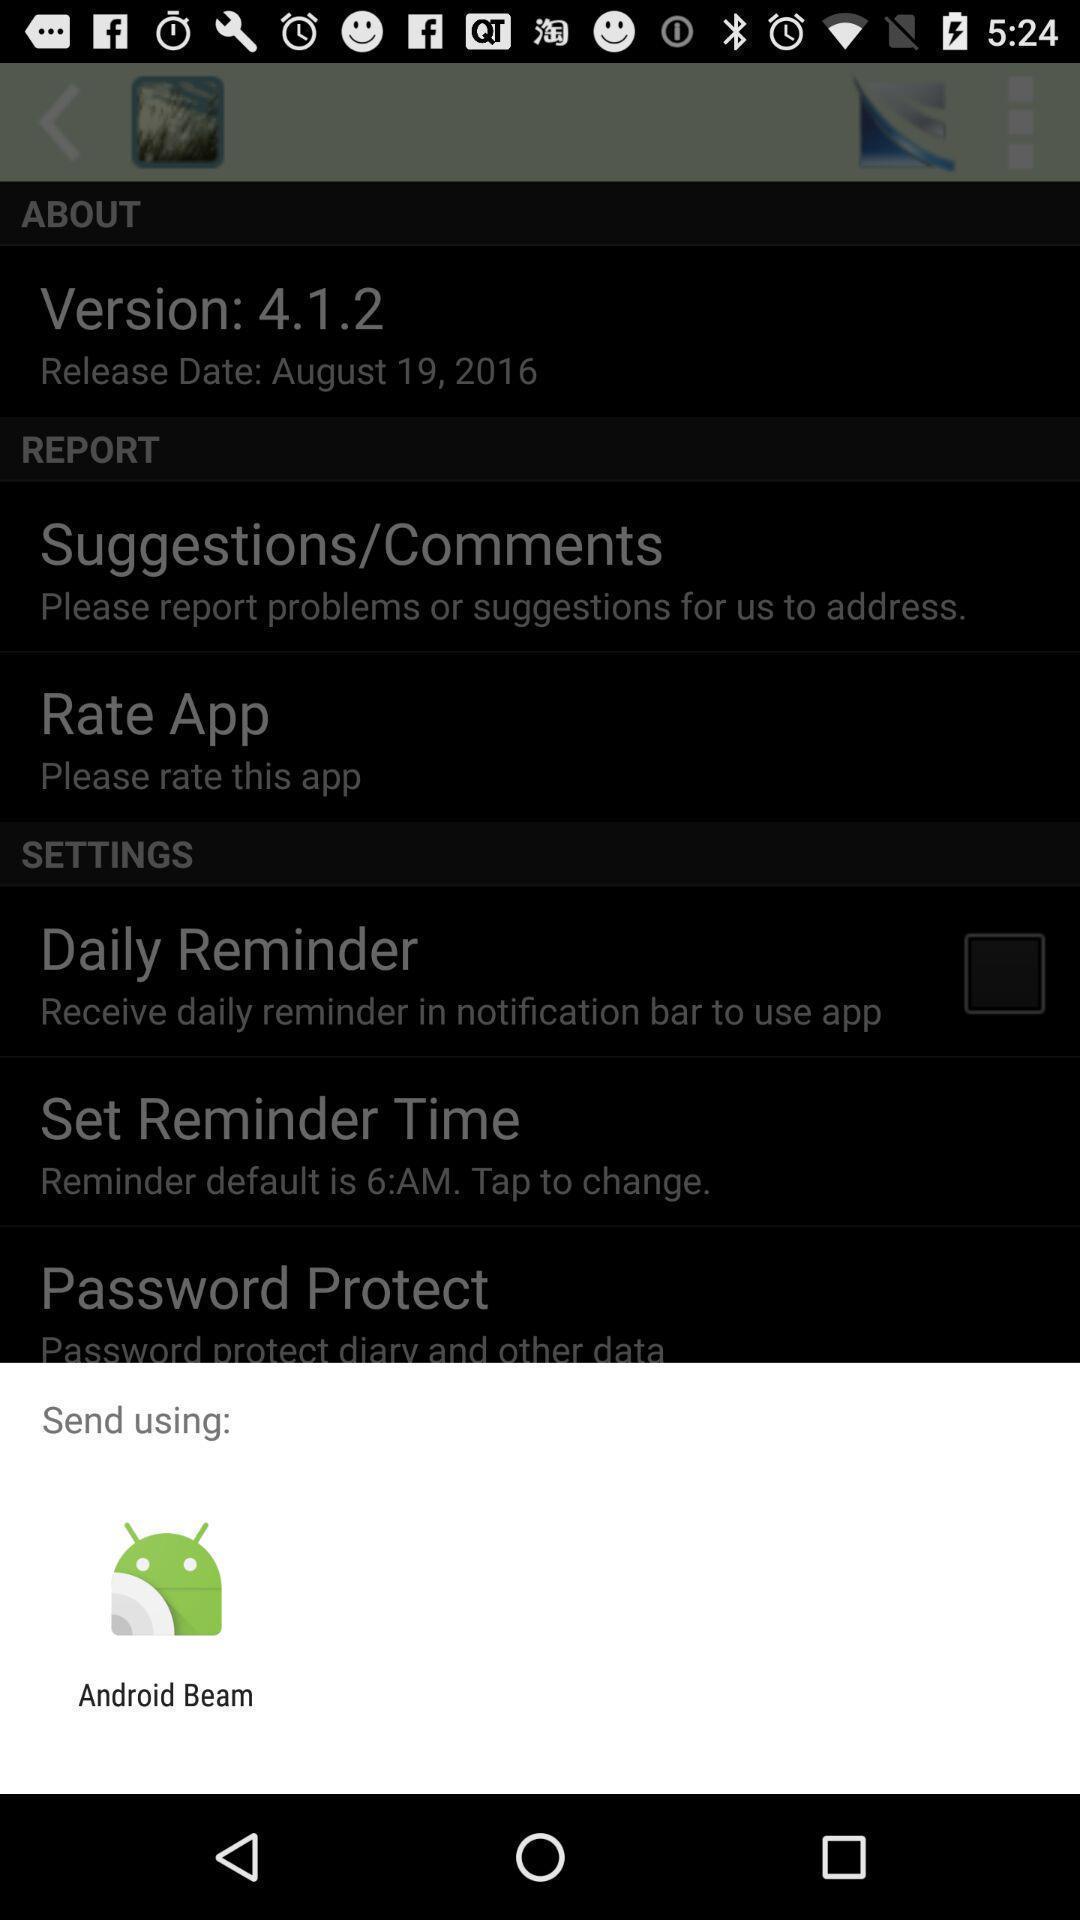Tell me about the visual elements in this screen capture. Popup of application to share the information. 